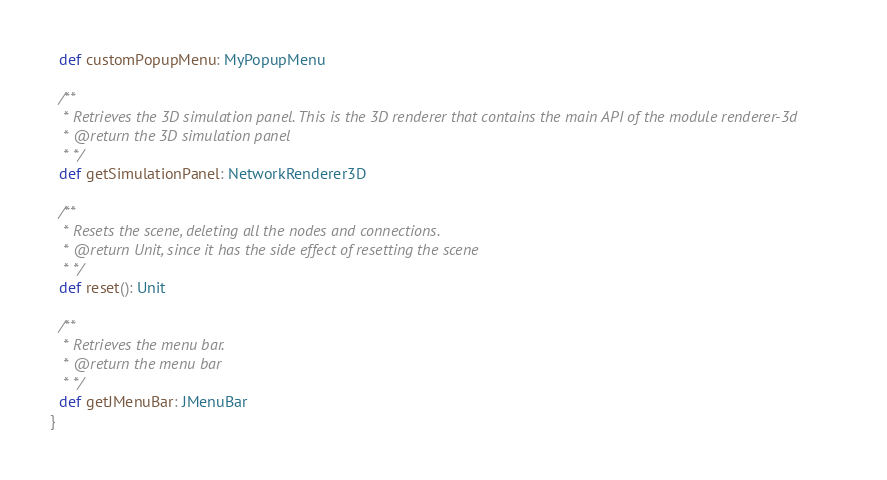<code> <loc_0><loc_0><loc_500><loc_500><_Scala_>  def customPopupMenu: MyPopupMenu

  /**
   * Retrieves the 3D simulation panel. This is the 3D renderer that contains the main API of the module renderer-3d
   * @return the 3D simulation panel
   * */
  def getSimulationPanel: NetworkRenderer3D

  /**
   * Resets the scene, deleting all the nodes and connections.
   * @return Unit, since it has the side effect of resetting the scene
   * */
  def reset(): Unit

  /**
   * Retrieves the menu bar.
   * @return the menu bar
   * */
  def getJMenuBar: JMenuBar
}

</code> 